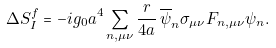<formula> <loc_0><loc_0><loc_500><loc_500>\Delta S ^ { f } _ { I } = - i g _ { 0 } a ^ { 4 } \sum _ { n , \mu \nu } \frac { r } { 4 a } \, \overline { \psi } _ { n } \sigma _ { \mu \nu } F _ { n , \mu \nu } \psi _ { n } .</formula> 